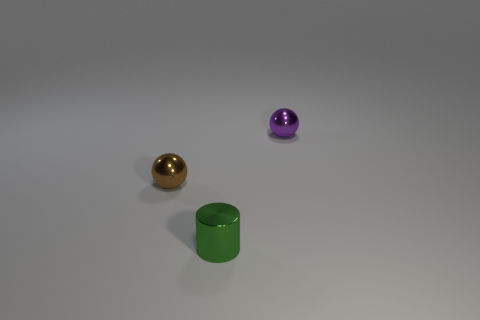Subtract all purple spheres. How many spheres are left? 1 Subtract all blue cylinders. How many cyan balls are left? 0 Add 3 small purple things. How many small purple things are left? 4 Add 3 tiny green objects. How many tiny green objects exist? 4 Add 1 small purple spheres. How many objects exist? 4 Subtract 0 cyan cylinders. How many objects are left? 3 Subtract all balls. How many objects are left? 1 Subtract 2 balls. How many balls are left? 0 Subtract all blue balls. Subtract all yellow cubes. How many balls are left? 2 Subtract all gray matte balls. Subtract all green cylinders. How many objects are left? 2 